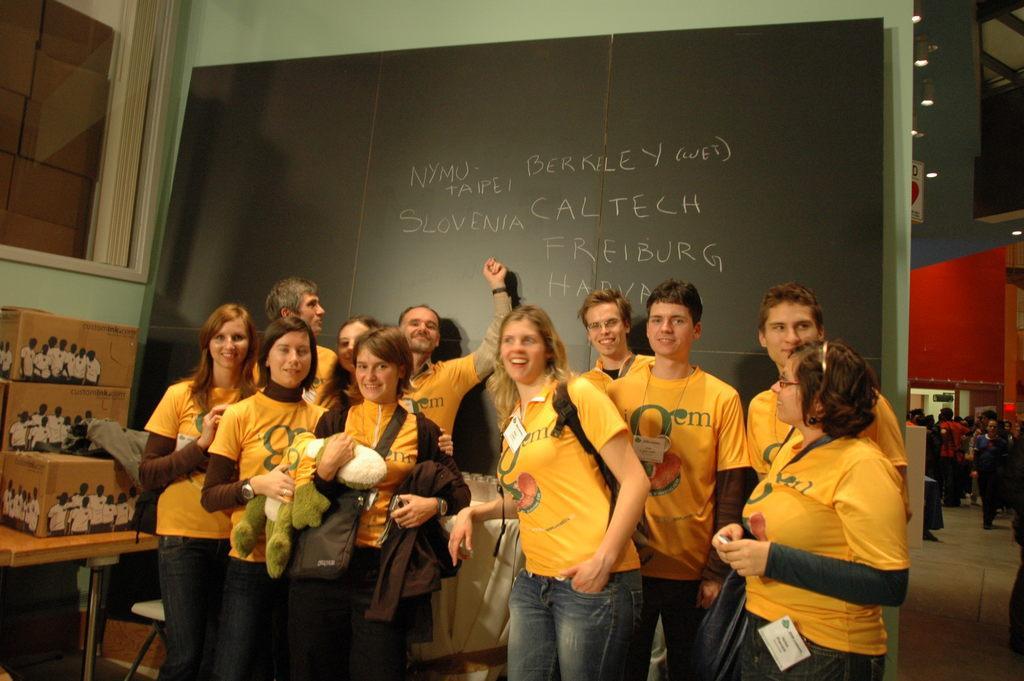Describe this image in one or two sentences. Here I can see few people wearing yellow color t-shirts, standing, smiling and giving pose for the picture. At the back of these people there is a blackboard on which I can see some text. On the left side there is a table on which few boxes are placed. In the top left-hand corner there is a window. In the background, I can see a crowd of people standing on the floor. At the top of the image there are few lights attached to the ceiling. 